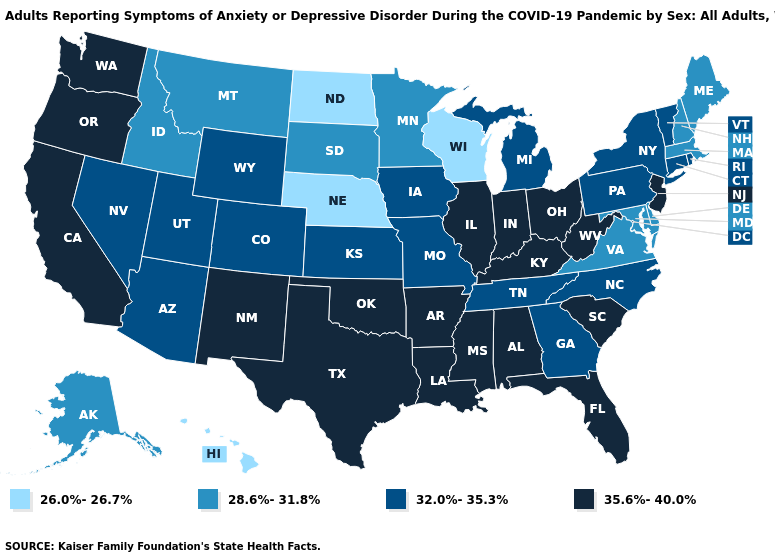Does Hawaii have the lowest value in the USA?
Concise answer only. Yes. Name the states that have a value in the range 26.0%-26.7%?
Write a very short answer. Hawaii, Nebraska, North Dakota, Wisconsin. What is the value of Tennessee?
Be succinct. 32.0%-35.3%. Does Hawaii have the lowest value in the West?
Give a very brief answer. Yes. Does Wisconsin have the lowest value in the USA?
Concise answer only. Yes. Name the states that have a value in the range 32.0%-35.3%?
Give a very brief answer. Arizona, Colorado, Connecticut, Georgia, Iowa, Kansas, Michigan, Missouri, Nevada, New York, North Carolina, Pennsylvania, Rhode Island, Tennessee, Utah, Vermont, Wyoming. Does Illinois have the highest value in the USA?
Quick response, please. Yes. What is the value of Nevada?
Short answer required. 32.0%-35.3%. Name the states that have a value in the range 28.6%-31.8%?
Give a very brief answer. Alaska, Delaware, Idaho, Maine, Maryland, Massachusetts, Minnesota, Montana, New Hampshire, South Dakota, Virginia. What is the highest value in the USA?
Concise answer only. 35.6%-40.0%. What is the highest value in the USA?
Keep it brief. 35.6%-40.0%. What is the value of Virginia?
Quick response, please. 28.6%-31.8%. What is the lowest value in the USA?
Be succinct. 26.0%-26.7%. Name the states that have a value in the range 26.0%-26.7%?
Be succinct. Hawaii, Nebraska, North Dakota, Wisconsin. 